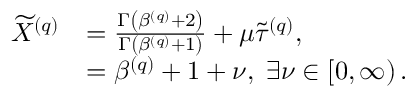Convert formula to latex. <formula><loc_0><loc_0><loc_500><loc_500>\begin{array} { r l } { \widetilde { X } ^ { \left ( q \right ) } } & { = \frac { \Gamma \left ( \beta ^ { \left ( q \right ) } + 2 \right ) } { \Gamma \left ( \beta ^ { \left ( q \right ) } + 1 \right ) } + \mu \widetilde { \tau } ^ { \left ( q \right ) } , } \\ & { = \beta ^ { \left ( q \right ) } + 1 + \nu , \, \exists \nu \in \left [ 0 , \infty \right ) . } \end{array}</formula> 